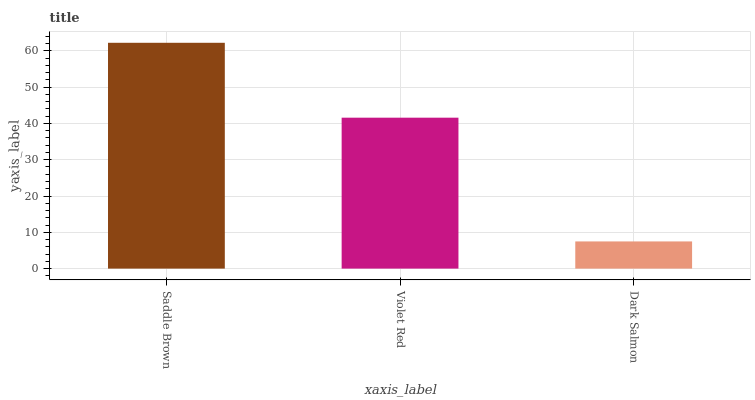Is Dark Salmon the minimum?
Answer yes or no. Yes. Is Saddle Brown the maximum?
Answer yes or no. Yes. Is Violet Red the minimum?
Answer yes or no. No. Is Violet Red the maximum?
Answer yes or no. No. Is Saddle Brown greater than Violet Red?
Answer yes or no. Yes. Is Violet Red less than Saddle Brown?
Answer yes or no. Yes. Is Violet Red greater than Saddle Brown?
Answer yes or no. No. Is Saddle Brown less than Violet Red?
Answer yes or no. No. Is Violet Red the high median?
Answer yes or no. Yes. Is Violet Red the low median?
Answer yes or no. Yes. Is Saddle Brown the high median?
Answer yes or no. No. Is Dark Salmon the low median?
Answer yes or no. No. 